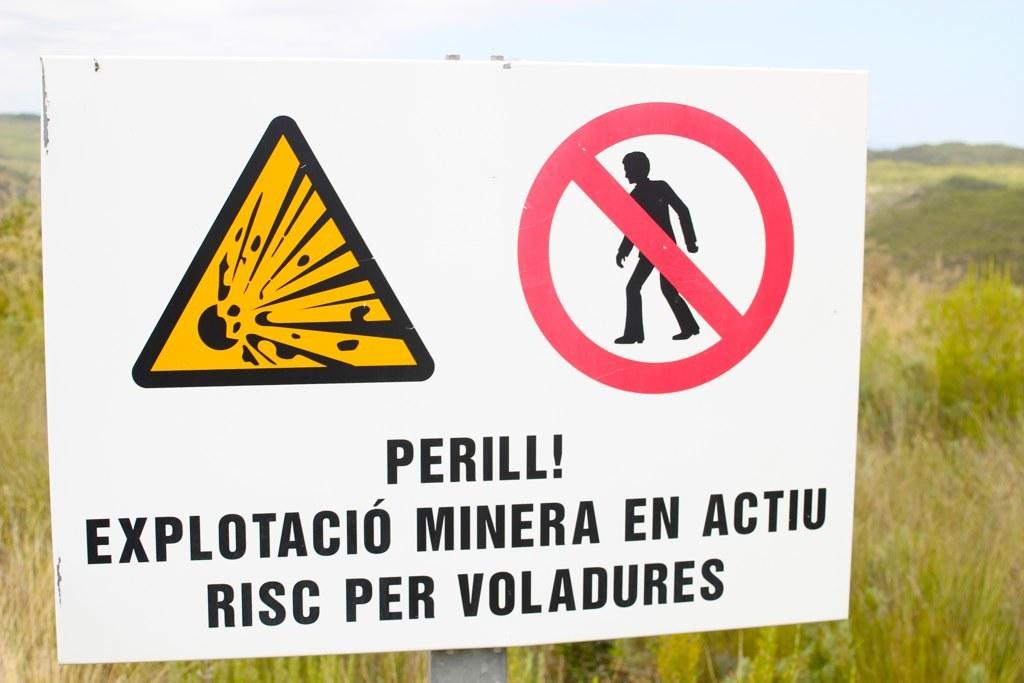<image>
Relay a brief, clear account of the picture shown. A warning sign in Catalan Spanish warning of mining blast danger. 